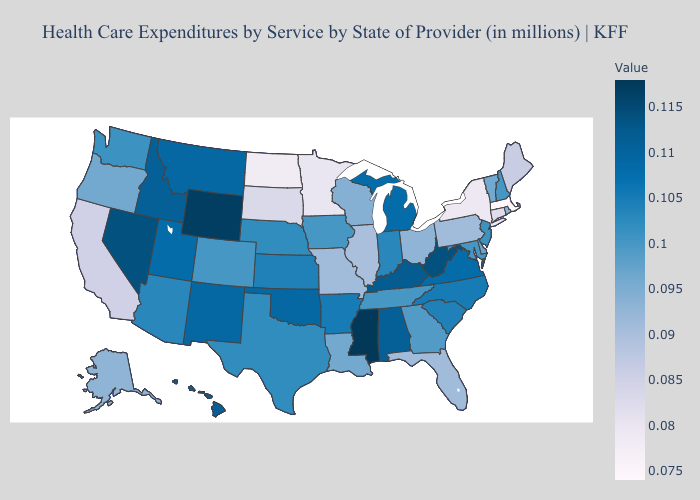Does Virginia have the lowest value in the USA?
Keep it brief. No. Does South Dakota have the lowest value in the MidWest?
Answer briefly. No. Which states hav the highest value in the MidWest?
Concise answer only. Michigan. Which states have the lowest value in the MidWest?
Be succinct. North Dakota. Among the states that border Oklahoma , which have the highest value?
Quick response, please. New Mexico. 